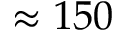<formula> <loc_0><loc_0><loc_500><loc_500>\approx 1 5 0</formula> 